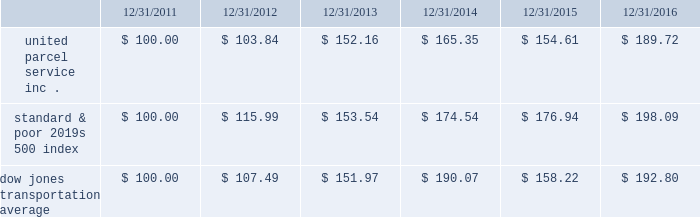Shareowner return performance graph the following performance graph and related information shall not be deemed 201csoliciting material 201d or to be 201cfiled 201d with the sec , nor shall such information be incorporated by reference into any future filing under the securities act of 1933 or securities exchange act of 1934 , each as amended , except to the extent that the company specifically incorporates such information by reference into such filing .
The following graph shows a five year comparison of cumulative total shareowners 2019 returns for our class b common stock , the standard & poor 2019s 500 index and the dow jones transportation average .
The comparison of the total cumulative return on investment , which is the change in the quarterly stock price plus reinvested dividends for each of the quarterly periods , assumes that $ 100 was invested on december 31 , 2011 in the standard & poor 2019s 500 index , the dow jones transportation average and our class b common stock. .

For the five year period ending 12/31/2016 what was the difference in total performance between united parcel service inc . and the standard & poor 2019s 500 index? 
Computations: (((189.72 - 100) / 100) - ((198.09 - 100) / 100))
Answer: -0.0837. 